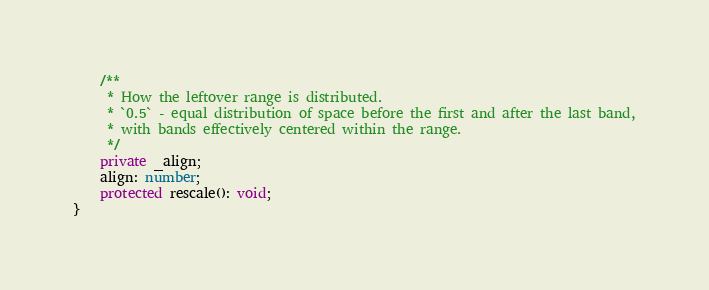Convert code to text. <code><loc_0><loc_0><loc_500><loc_500><_TypeScript_>    /**
     * How the leftover range is distributed.
     * `0.5` - equal distribution of space before the first and after the last band,
     * with bands effectively centered within the range.
     */
    private _align;
    align: number;
    protected rescale(): void;
}
</code> 